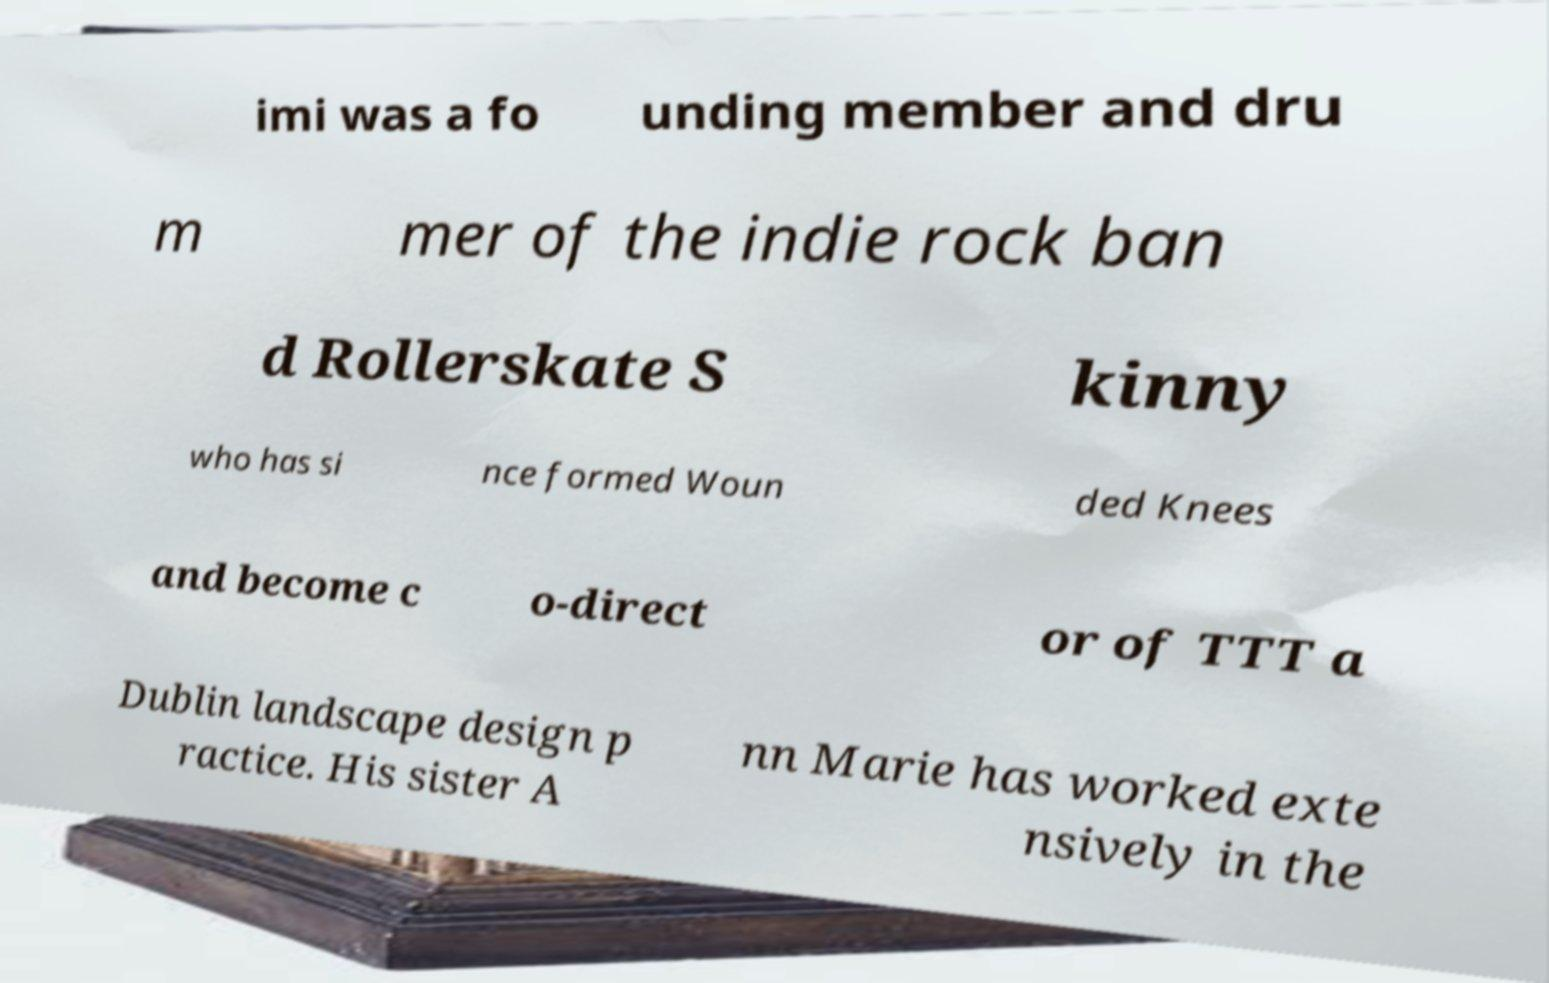Could you assist in decoding the text presented in this image and type it out clearly? imi was a fo unding member and dru m mer of the indie rock ban d Rollerskate S kinny who has si nce formed Woun ded Knees and become c o-direct or of TTT a Dublin landscape design p ractice. His sister A nn Marie has worked exte nsively in the 